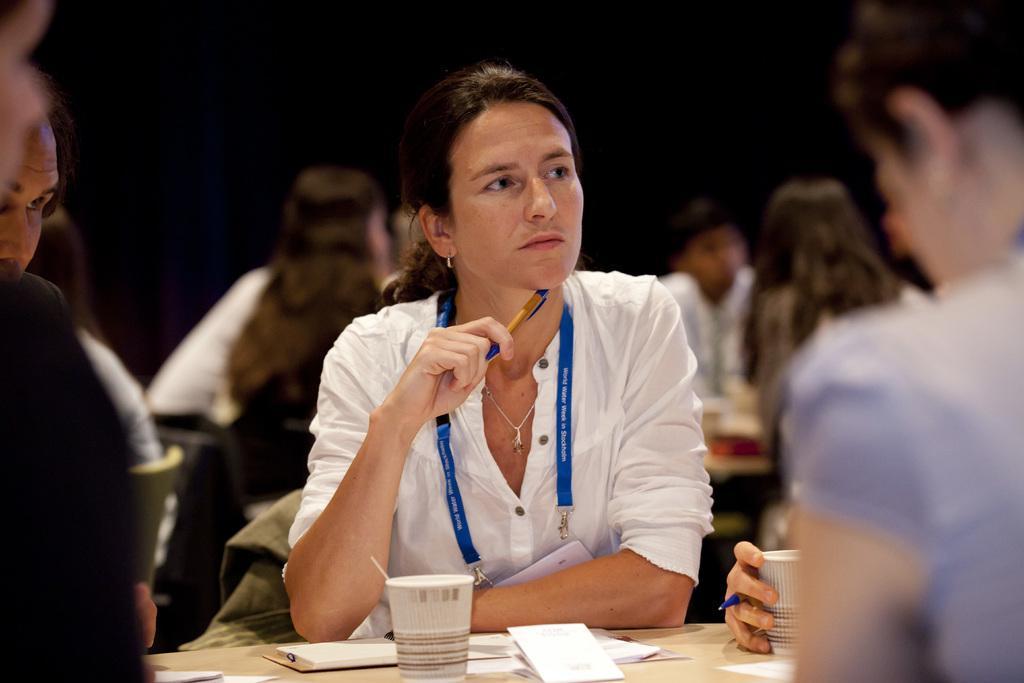Describe this image in one or two sentences. In this image we can see a woman sitting and wearing a lanyard and holding a pen. And we can see a glass, and some other objects on the table. And we can see the surrounding people. 